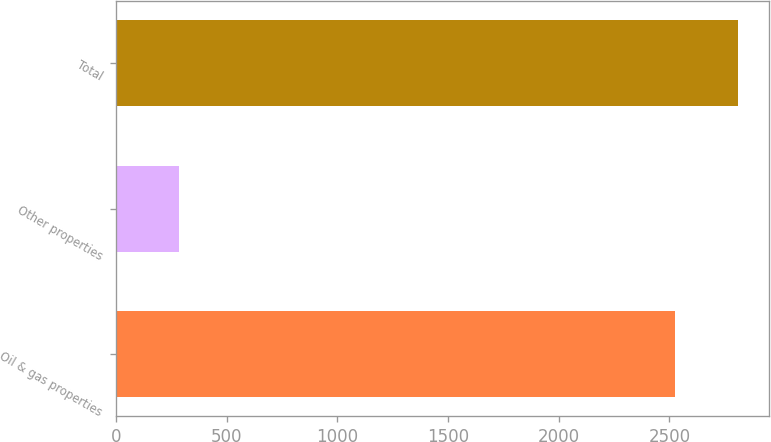<chart> <loc_0><loc_0><loc_500><loc_500><bar_chart><fcel>Oil & gas properties<fcel>Other properties<fcel>Total<nl><fcel>2526<fcel>285<fcel>2811<nl></chart> 